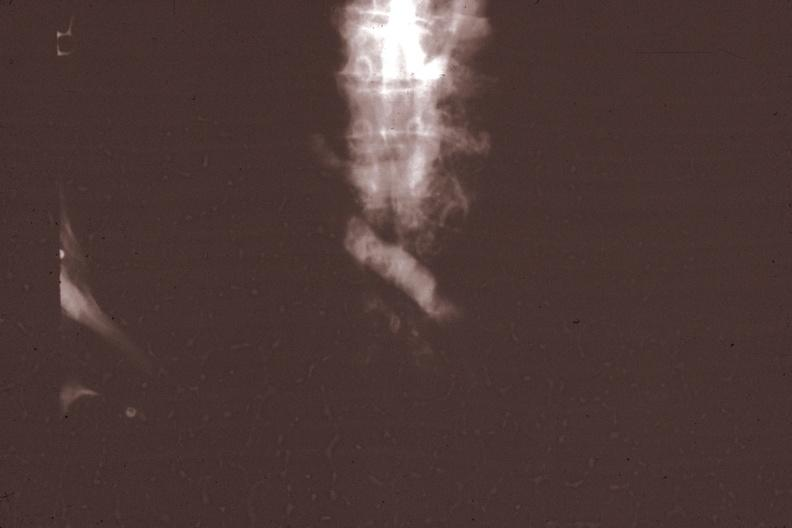s thymus present?
Answer the question using a single word or phrase. Yes 